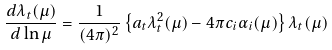<formula> <loc_0><loc_0><loc_500><loc_500>\frac { d \lambda _ { t } ( \mu ) } { d \ln \mu } = \frac { 1 } { ( 4 \pi ) ^ { 2 } } \left \{ a _ { t } \lambda _ { t } ^ { 2 } ( \mu ) - 4 \pi c _ { i } \alpha _ { i } ( \mu ) \right \} \lambda _ { t } ( \mu )</formula> 